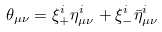<formula> <loc_0><loc_0><loc_500><loc_500>\theta _ { \mu \nu } = \xi _ { + } ^ { i } \eta _ { \mu \nu } ^ { i } + \xi _ { - } ^ { i } \bar { \eta } _ { \mu \nu } ^ { i }</formula> 